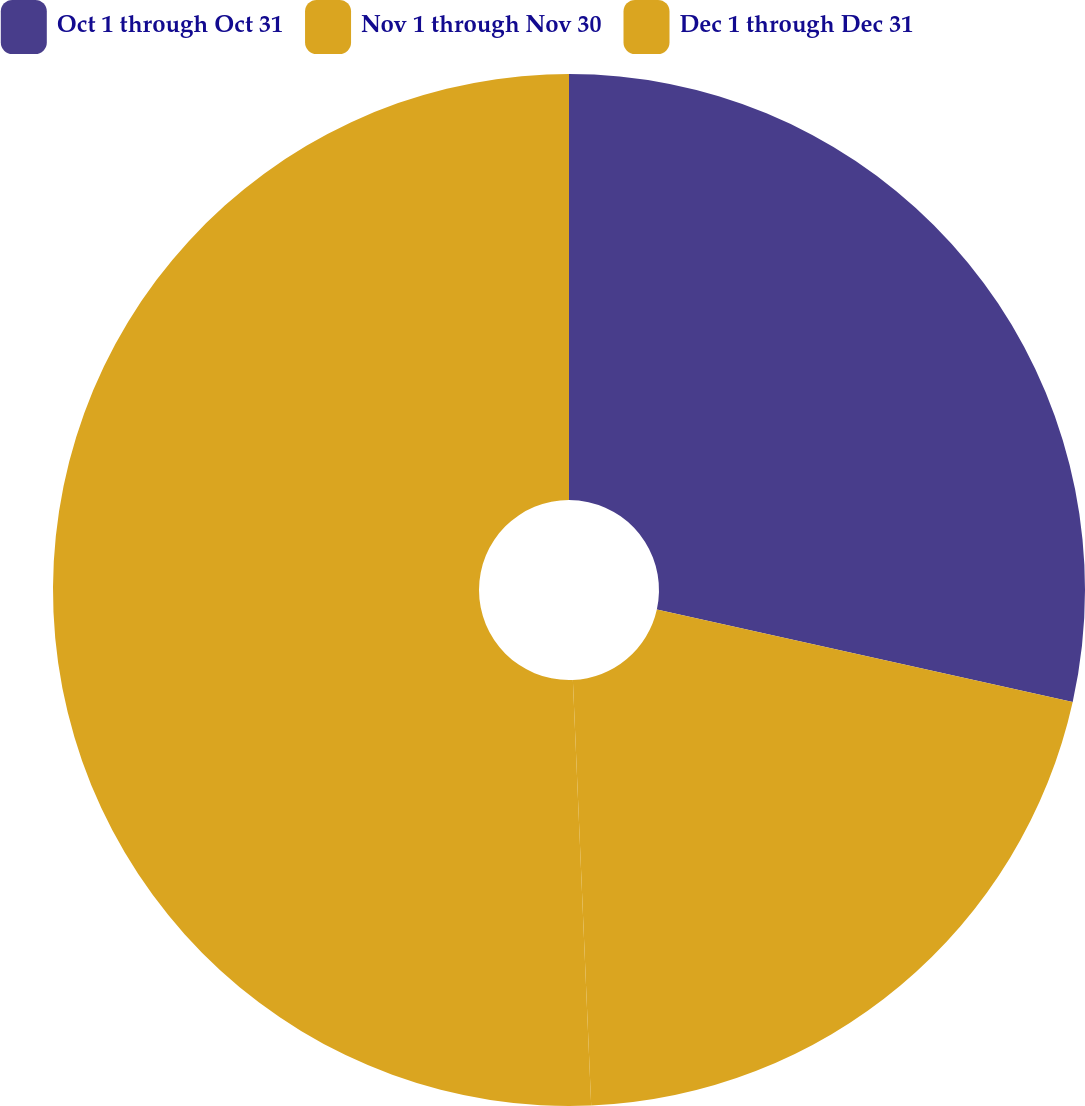Convert chart to OTSL. <chart><loc_0><loc_0><loc_500><loc_500><pie_chart><fcel>Oct 1 through Oct 31<fcel>Nov 1 through Nov 30<fcel>Dec 1 through Dec 31<nl><fcel>28.48%<fcel>20.83%<fcel>50.68%<nl></chart> 